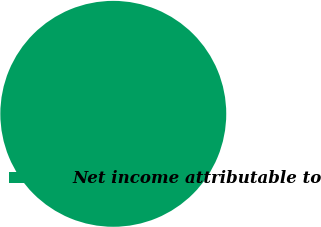Convert chart. <chart><loc_0><loc_0><loc_500><loc_500><pie_chart><fcel>Net income attributable to<nl><fcel>100.0%<nl></chart> 